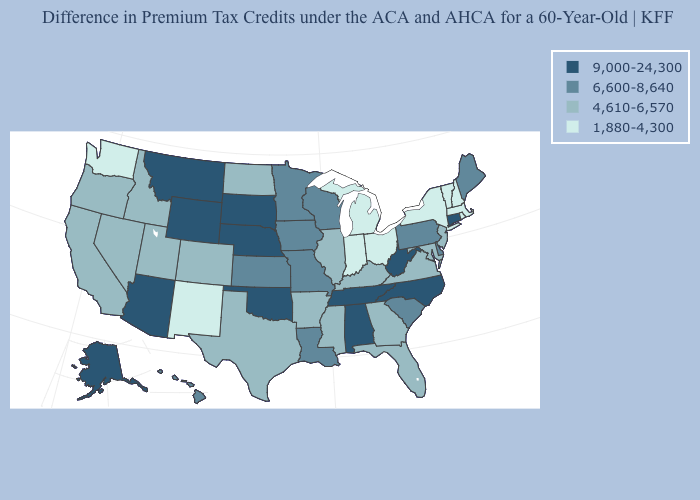Among the states that border Oregon , does Washington have the lowest value?
Short answer required. Yes. Name the states that have a value in the range 4,610-6,570?
Write a very short answer. Arkansas, California, Colorado, Florida, Georgia, Idaho, Illinois, Kentucky, Maryland, Mississippi, Nevada, New Jersey, North Dakota, Oregon, Texas, Utah, Virginia. Among the states that border Washington , which have the highest value?
Concise answer only. Idaho, Oregon. Does the map have missing data?
Give a very brief answer. No. Among the states that border New Mexico , which have the highest value?
Concise answer only. Arizona, Oklahoma. Which states have the lowest value in the West?
Be succinct. New Mexico, Washington. Among the states that border Vermont , which have the highest value?
Write a very short answer. Massachusetts, New Hampshire, New York. What is the lowest value in states that border Kentucky?
Be succinct. 1,880-4,300. Among the states that border Delaware , which have the highest value?
Be succinct. Pennsylvania. What is the lowest value in states that border Florida?
Short answer required. 4,610-6,570. Does North Carolina have the highest value in the USA?
Short answer required. Yes. How many symbols are there in the legend?
Quick response, please. 4. Name the states that have a value in the range 9,000-24,300?
Be succinct. Alabama, Alaska, Arizona, Connecticut, Montana, Nebraska, North Carolina, Oklahoma, South Dakota, Tennessee, West Virginia, Wyoming. Name the states that have a value in the range 9,000-24,300?
Answer briefly. Alabama, Alaska, Arizona, Connecticut, Montana, Nebraska, North Carolina, Oklahoma, South Dakota, Tennessee, West Virginia, Wyoming. 